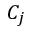<formula> <loc_0><loc_0><loc_500><loc_500>C _ { j }</formula> 